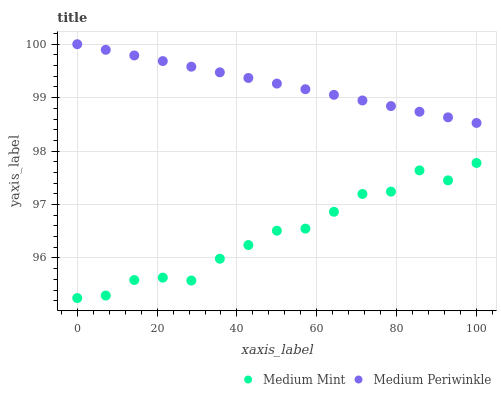Does Medium Mint have the minimum area under the curve?
Answer yes or no. Yes. Does Medium Periwinkle have the maximum area under the curve?
Answer yes or no. Yes. Does Medium Periwinkle have the minimum area under the curve?
Answer yes or no. No. Is Medium Periwinkle the smoothest?
Answer yes or no. Yes. Is Medium Mint the roughest?
Answer yes or no. Yes. Is Medium Periwinkle the roughest?
Answer yes or no. No. Does Medium Mint have the lowest value?
Answer yes or no. Yes. Does Medium Periwinkle have the lowest value?
Answer yes or no. No. Does Medium Periwinkle have the highest value?
Answer yes or no. Yes. Is Medium Mint less than Medium Periwinkle?
Answer yes or no. Yes. Is Medium Periwinkle greater than Medium Mint?
Answer yes or no. Yes. Does Medium Mint intersect Medium Periwinkle?
Answer yes or no. No. 